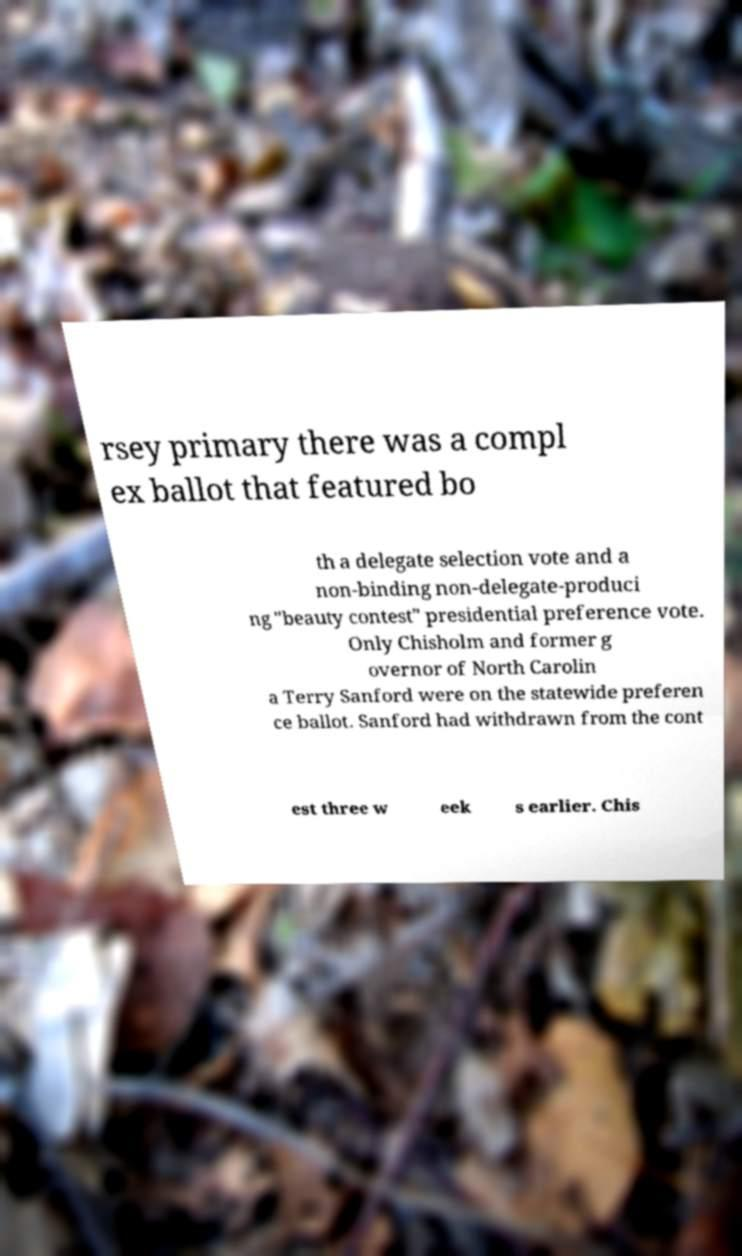Can you accurately transcribe the text from the provided image for me? rsey primary there was a compl ex ballot that featured bo th a delegate selection vote and a non-binding non-delegate-produci ng "beauty contest" presidential preference vote. Only Chisholm and former g overnor of North Carolin a Terry Sanford were on the statewide preferen ce ballot. Sanford had withdrawn from the cont est three w eek s earlier. Chis 